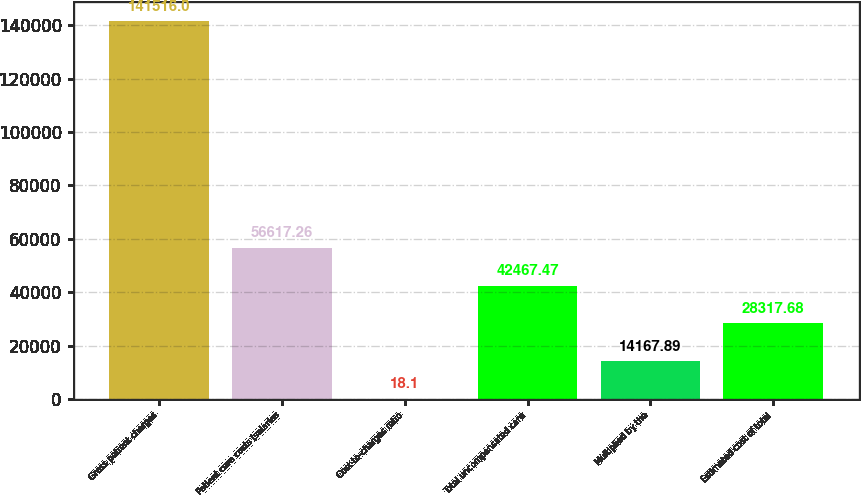Convert chart. <chart><loc_0><loc_0><loc_500><loc_500><bar_chart><fcel>Gross patient charges<fcel>Patient care costs (salaries<fcel>Cost-to-charges ratio<fcel>Total uncompensated care<fcel>Multiplied by the<fcel>Estimated cost of total<nl><fcel>141516<fcel>56617.3<fcel>18.1<fcel>42467.5<fcel>14167.9<fcel>28317.7<nl></chart> 